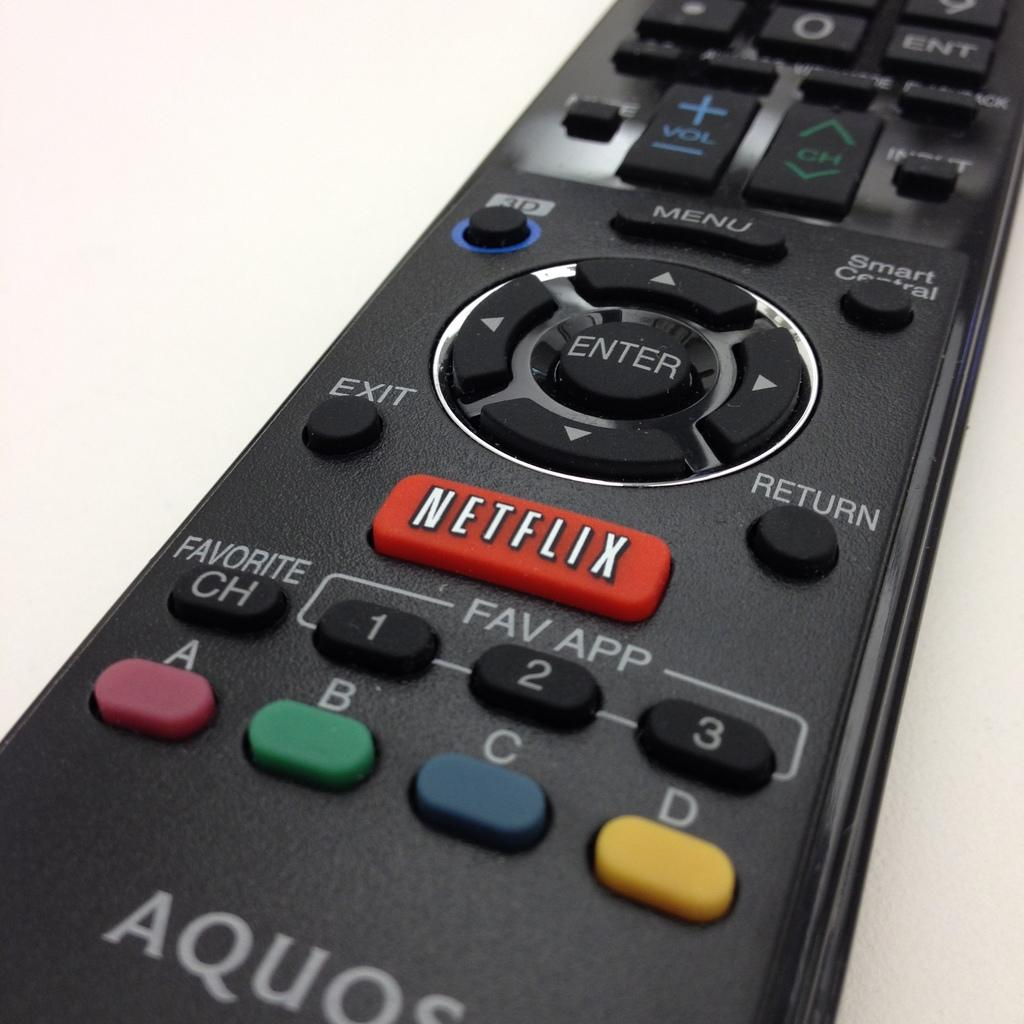<image>
Offer a succinct explanation of the picture presented. An Aquos, black, remote control containing different buttons including Netflix, Favorite, Menu, Enter and more. 